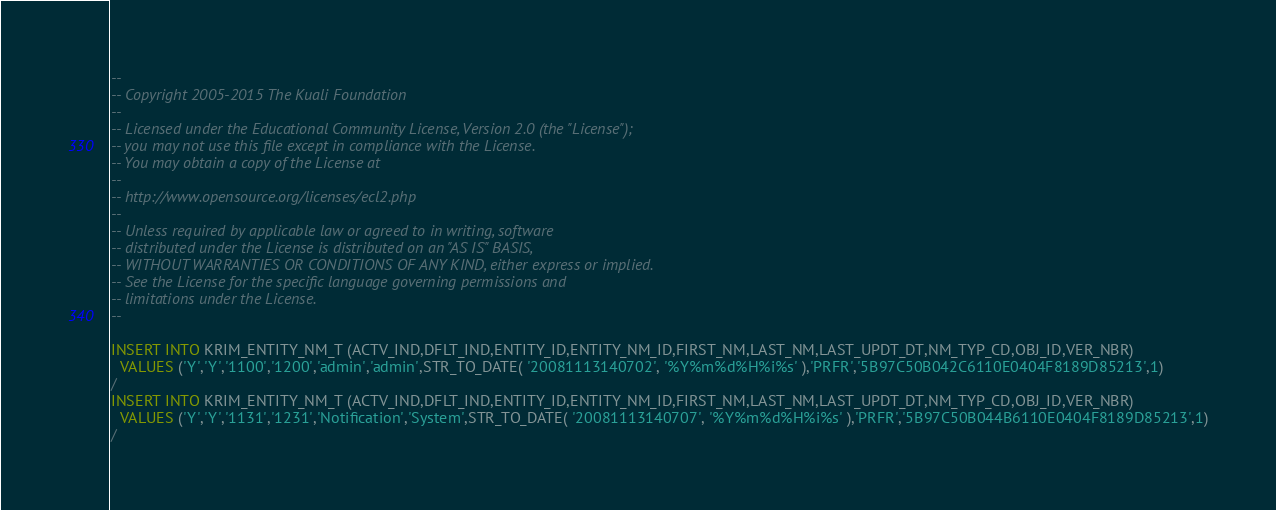Convert code to text. <code><loc_0><loc_0><loc_500><loc_500><_SQL_>--
-- Copyright 2005-2015 The Kuali Foundation
--
-- Licensed under the Educational Community License, Version 2.0 (the "License");
-- you may not use this file except in compliance with the License.
-- You may obtain a copy of the License at
--
-- http://www.opensource.org/licenses/ecl2.php
--
-- Unless required by applicable law or agreed to in writing, software
-- distributed under the License is distributed on an "AS IS" BASIS,
-- WITHOUT WARRANTIES OR CONDITIONS OF ANY KIND, either express or implied.
-- See the License for the specific language governing permissions and
-- limitations under the License.
--

INSERT INTO KRIM_ENTITY_NM_T (ACTV_IND,DFLT_IND,ENTITY_ID,ENTITY_NM_ID,FIRST_NM,LAST_NM,LAST_UPDT_DT,NM_TYP_CD,OBJ_ID,VER_NBR)
  VALUES ('Y','Y','1100','1200','admin','admin',STR_TO_DATE( '20081113140702', '%Y%m%d%H%i%s' ),'PRFR','5B97C50B042C6110E0404F8189D85213',1)
/
INSERT INTO KRIM_ENTITY_NM_T (ACTV_IND,DFLT_IND,ENTITY_ID,ENTITY_NM_ID,FIRST_NM,LAST_NM,LAST_UPDT_DT,NM_TYP_CD,OBJ_ID,VER_NBR)
  VALUES ('Y','Y','1131','1231','Notification','System',STR_TO_DATE( '20081113140707', '%Y%m%d%H%i%s' ),'PRFR','5B97C50B044B6110E0404F8189D85213',1)
/
</code> 